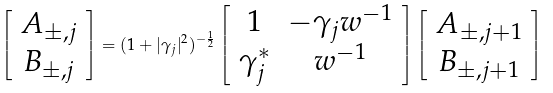<formula> <loc_0><loc_0><loc_500><loc_500>\left [ \begin{array} { c } A _ { \pm , j } \\ B _ { \pm , j } \end{array} \right ] = ( 1 + | \gamma _ { j } | ^ { 2 } ) ^ { - \frac { 1 } { 2 } } \left [ \begin{array} { c c } 1 & - \gamma _ { j } w ^ { - 1 } \\ \gamma _ { j } ^ { * } & w ^ { - 1 } \end{array} \right ] \left [ \begin{array} { c } A _ { \pm , j + 1 } \\ B _ { \pm , j + 1 } \end{array} \right ]</formula> 